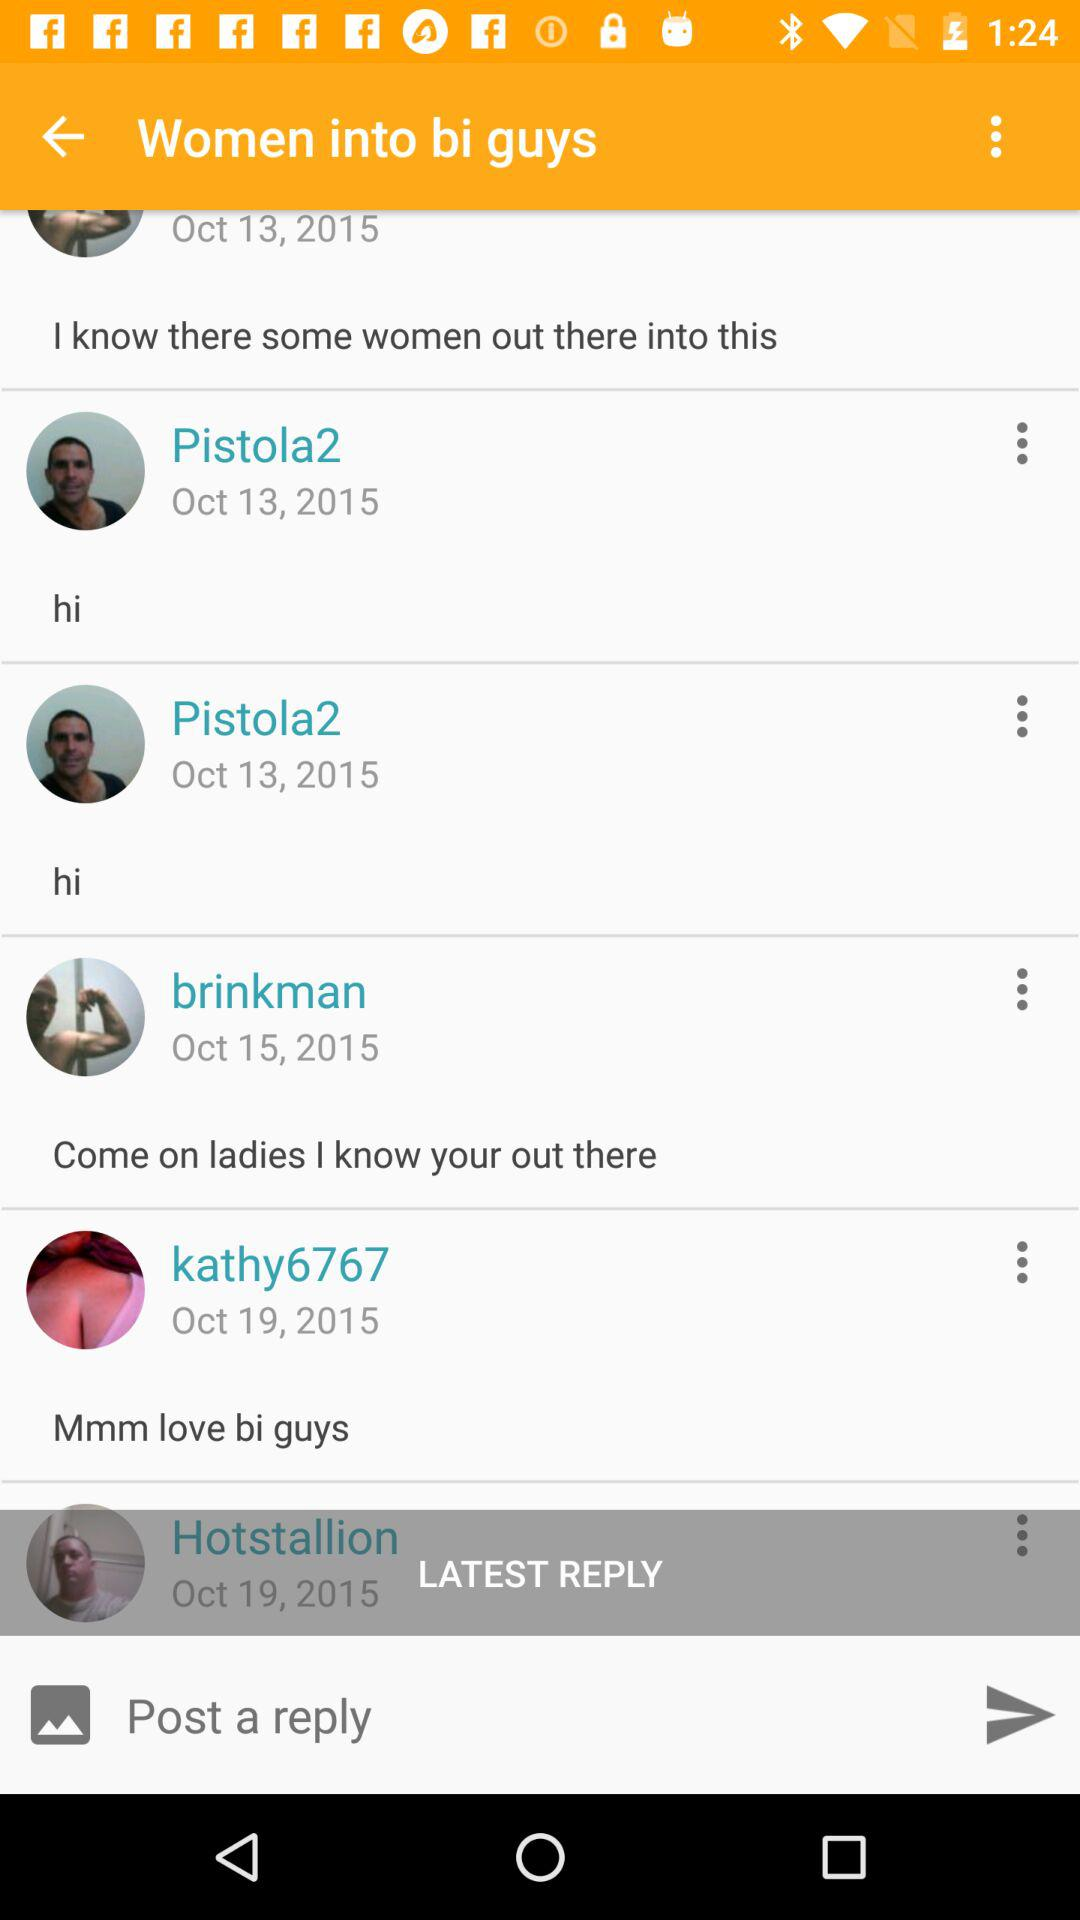How many of the posts are by the same person?
Answer the question using a single word or phrase. 2 